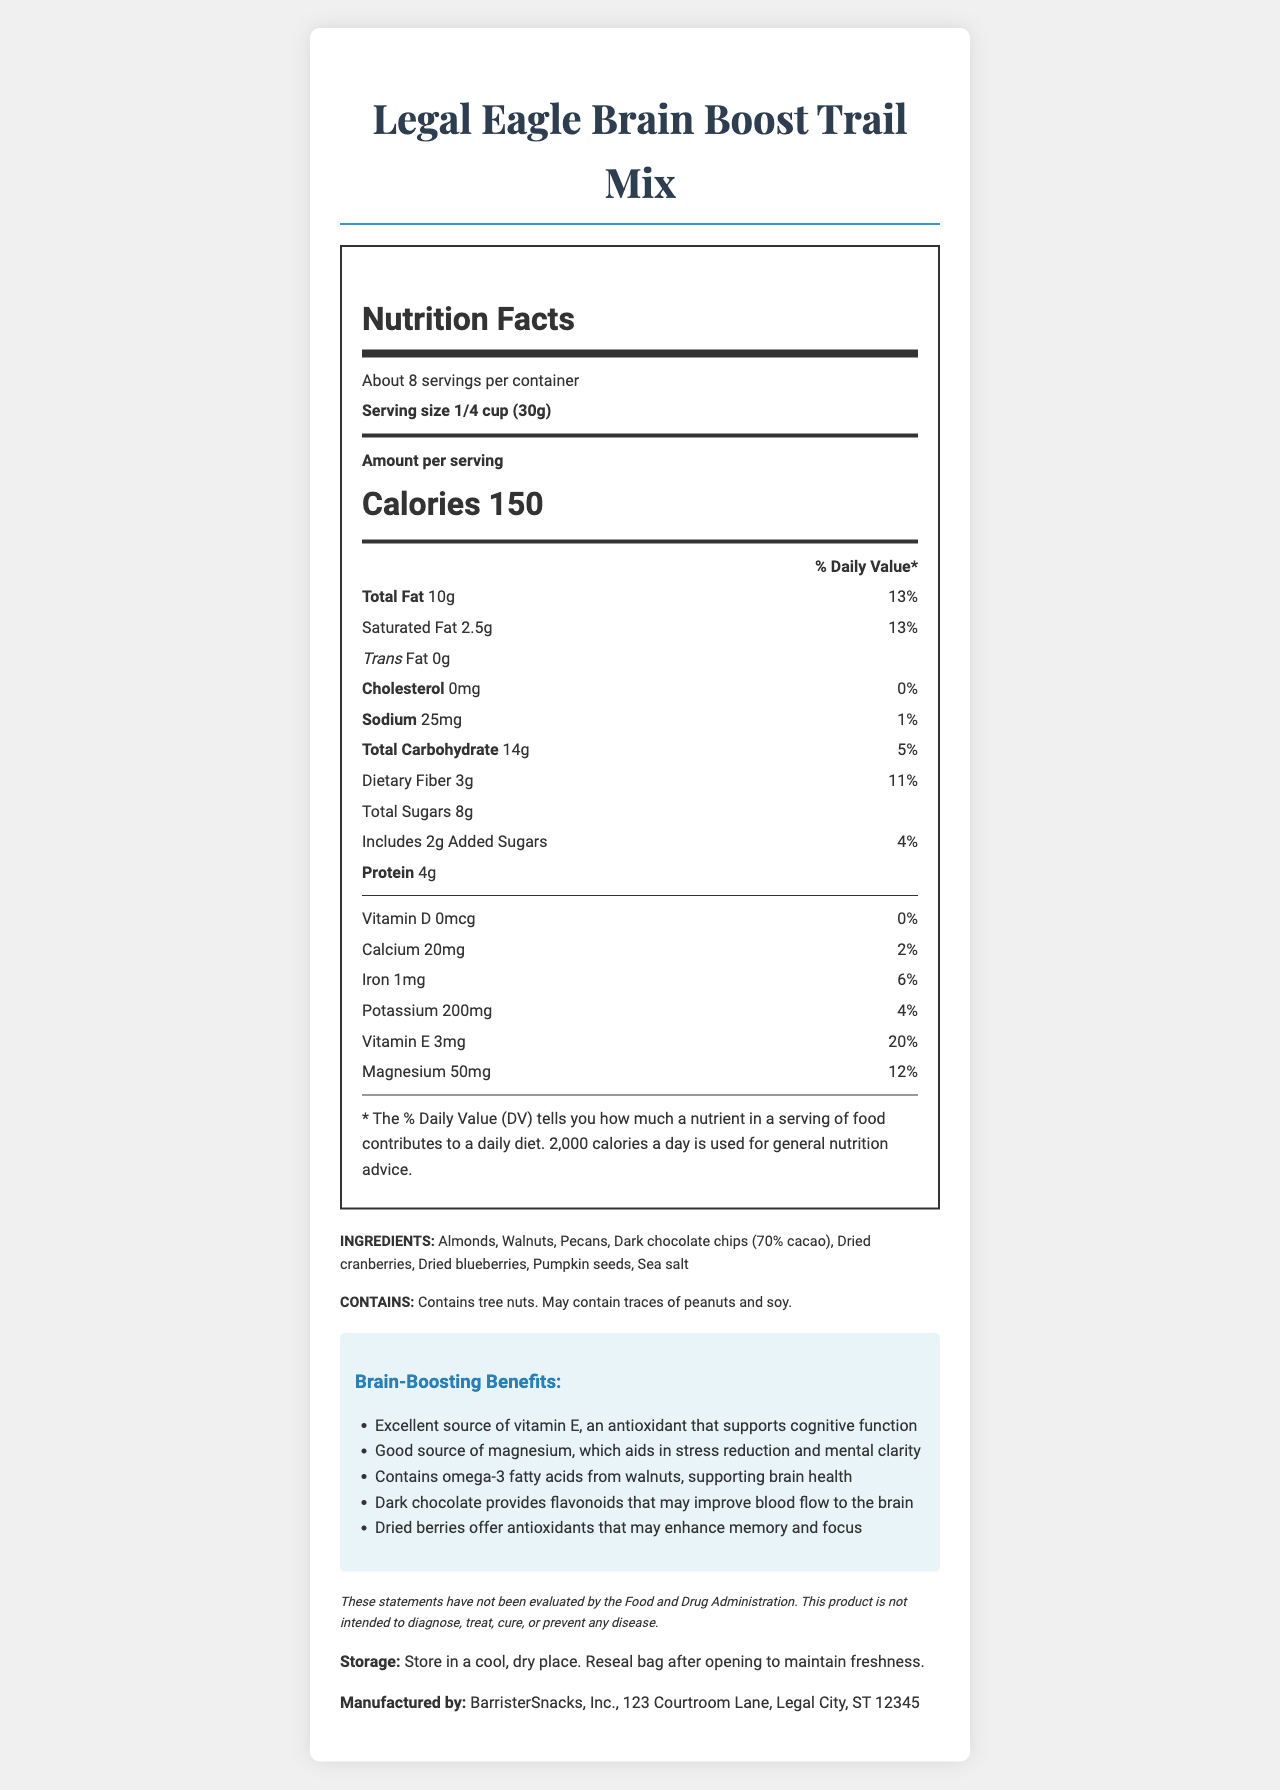what is the serving size for the Legal Eagle Brain Boost Trail Mix? The serving size is explicitly mentioned in the "Nutrition Facts" section under "Serving size."
Answer: 1/4 cup (30g) how many calories are in a serving of the trail mix? The calories per serving are directly provided under "Amount per serving."
Answer: 150 which ingredient provides omega-3 fatty acids? One of the health claims mentions that omega-3 fatty acids come from walnuts.
Answer: Walnuts What are the ingredients in the Legal Eagle Brain Boost Trail Mix? The ingredients list is explicitly mentioned under "INGREDIENTS."
Answer: Almonds, Walnuts, Pecans, Dark chocolate chips (70% cacao), Dried cranberries, Dried blueberries, Pumpkin seeds, Sea salt how much dietary fiber does one serving contain? The amount of dietary fiber per serving is listed under "Dietary Fiber" in the Nutrition Facts section.
Answer: 3g which nutrient has the highest daily value percentage in one serving? A. Vitamin E B. Calcium C. Iron D. Magnesium Vitamin E has a daily value of 20%, which is higher than the other listed nutrients.
Answer: A. Vitamin E which company manufactures the Legal Eagle Brain Boost Trail Mix? A. Courtroom Snacks, Inc. B. Legal Bites, Inc. C. BarristerSnacks, Inc. D. Attorney Treats, LLC The manufacturer is listed at the bottom of the document as "BarristerSnacks, Inc."
Answer: C. BarristerSnacks, Inc. is this trail mix free from trans fat? The Nutrition Facts section shows "Trans Fat 0g."
Answer: Yes describe the main idea of this document. The document presents both the nutrition facts and the beneficial claims of the trail mix, with a focus on brain health and the attorney demographic.
Answer: The document provides detailed nutritional information, ingredients, and health benefits for the Legal Eagle Brain Boost Trail Mix, a snack targeting attorneys and containing nuts, dark chocolate, and dried berries. It emphasizes cognitive benefits and lists the nutrient content per serving. how much iron is in one serving, and what percentage of the daily value does it represent? The amount of iron and its daily value percentage are both specified in the Nutrition Facts section.
Answer: 1mg, 6% where should the trail mix be stored after opening? The storage instructions are explicitly mentioned at the bottom of the document.
Answer: In a cool, dry place; reseal bag after opening to maintain freshness. what is the address of the manufacturer? This information is provided in the manufacturing details at the bottom of the document.
Answer: 123 Courtroom Lane, Legal City, ST 12345 does the document mention the specific amount of omega-3 fatty acids? The document mentions omega-3 fatty acids from walnuts but does not state the specific amount.
Answer: Not enough information what are the benefits of dark chocolate in this trail mix according to the document? The health claim about dark chocolate is directly stated in the health benefits section of the document.
Answer: Dark chocolate provides flavonoids that may improve blood flow to the brain. how much total carbohydrate does one serving of this trail mix contain? The total carbohydrate content is specified in the Nutrition Facts section.
Answer: 14g 